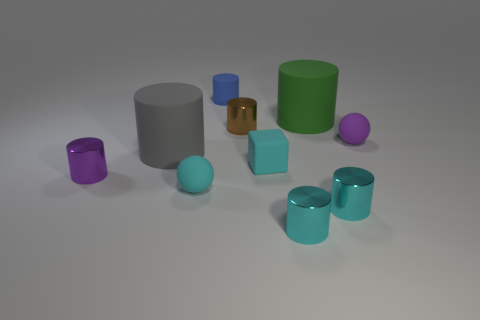There is a purple cylinder; is it the same size as the purple thing that is right of the small brown shiny cylinder?
Ensure brevity in your answer.  Yes. How many shiny things are big gray blocks or large cylinders?
Your answer should be very brief. 0. Are there any other things that are made of the same material as the big gray thing?
Ensure brevity in your answer.  Yes. Does the tiny matte block have the same color as the small ball to the left of the small cyan matte cube?
Your response must be concise. Yes. The gray thing has what shape?
Your answer should be compact. Cylinder. What size is the purple thing right of the tiny metal cylinder to the left of the small shiny cylinder behind the tiny purple metal object?
Make the answer very short. Small. How many other objects are the same shape as the blue object?
Provide a short and direct response. 6. Does the tiny matte thing to the right of the big green matte thing have the same shape as the large rubber thing right of the large gray matte object?
Ensure brevity in your answer.  No. How many blocks are small red metallic objects or gray objects?
Offer a terse response. 0. What is the material of the tiny purple thing that is in front of the rubber sphere on the right side of the tiny sphere that is to the left of the large green matte cylinder?
Ensure brevity in your answer.  Metal. 